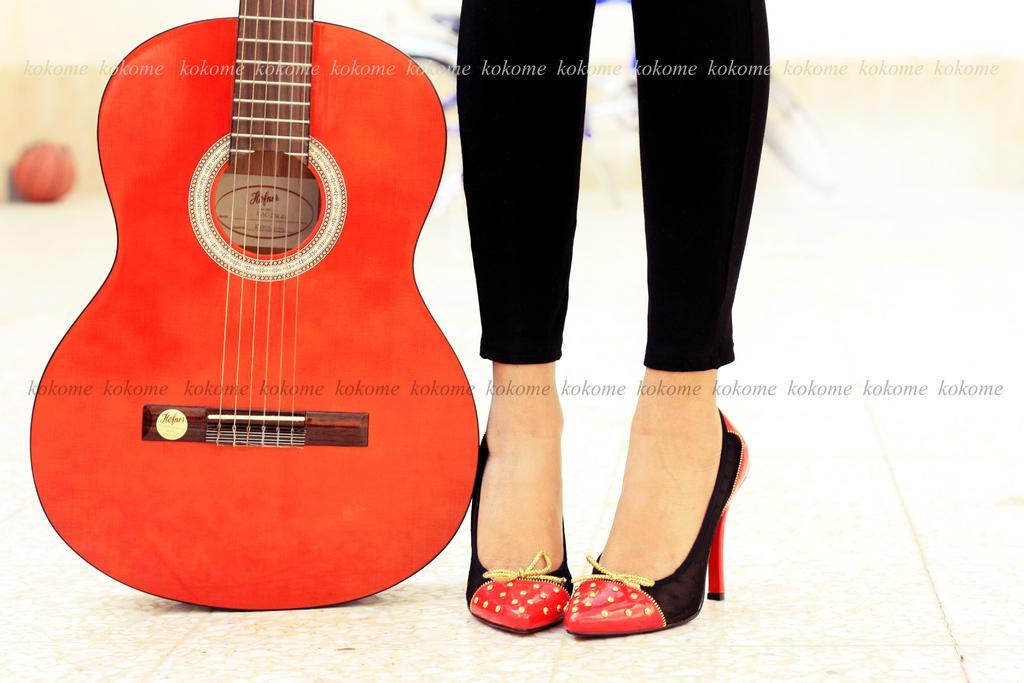In one or two sentences, can you explain what this image depicts? In the left it's a red color guitar and in the right girl is wearing the shoes black color trouser. 